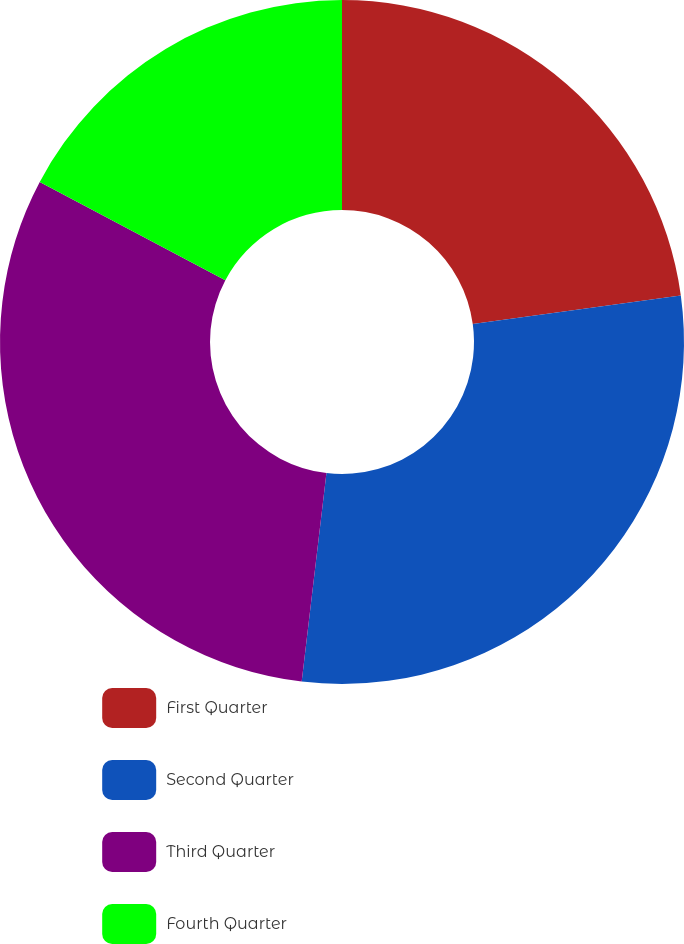<chart> <loc_0><loc_0><loc_500><loc_500><pie_chart><fcel>First Quarter<fcel>Second Quarter<fcel>Third Quarter<fcel>Fourth Quarter<nl><fcel>22.83%<fcel>29.05%<fcel>30.87%<fcel>17.25%<nl></chart> 